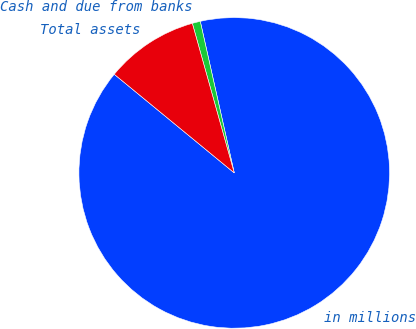Convert chart to OTSL. <chart><loc_0><loc_0><loc_500><loc_500><pie_chart><fcel>in millions<fcel>Cash and due from banks<fcel>Total assets<nl><fcel>89.45%<fcel>0.84%<fcel>9.7%<nl></chart> 